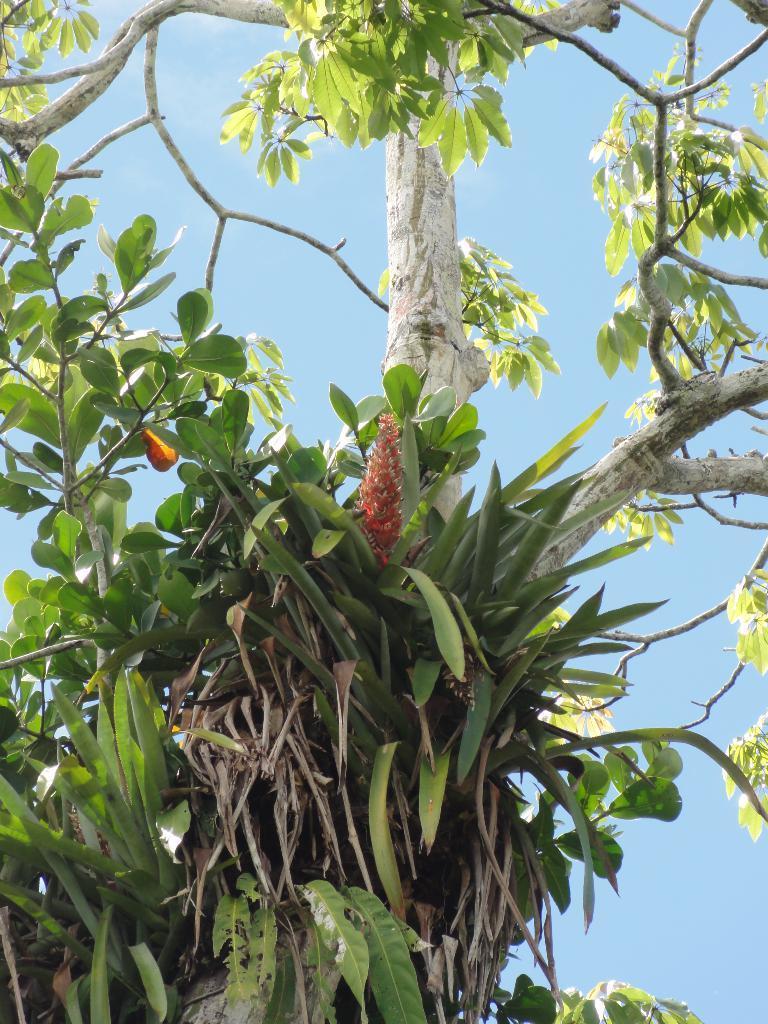Please provide a concise description of this image. In this image we can see a plant and a tree. In the background we can see the sky. 